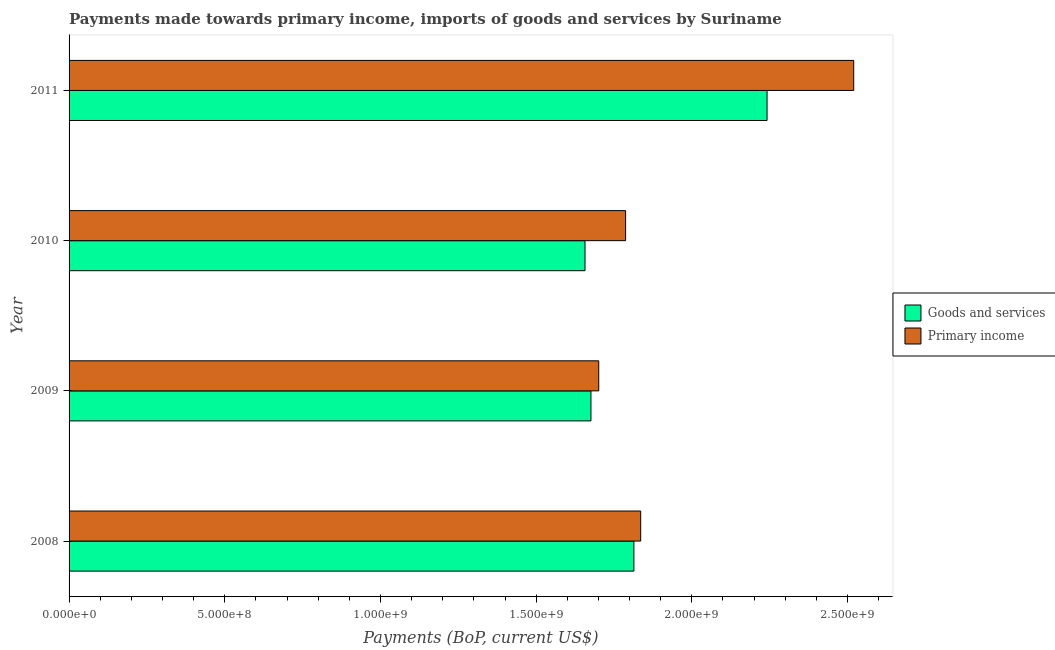How many different coloured bars are there?
Provide a succinct answer. 2. Are the number of bars on each tick of the Y-axis equal?
Provide a short and direct response. Yes. How many bars are there on the 3rd tick from the top?
Your answer should be compact. 2. What is the label of the 1st group of bars from the top?
Provide a succinct answer. 2011. In how many cases, is the number of bars for a given year not equal to the number of legend labels?
Give a very brief answer. 0. What is the payments made towards primary income in 2010?
Keep it short and to the point. 1.79e+09. Across all years, what is the maximum payments made towards primary income?
Give a very brief answer. 2.52e+09. Across all years, what is the minimum payments made towards goods and services?
Give a very brief answer. 1.66e+09. In which year was the payments made towards goods and services minimum?
Your answer should be very brief. 2010. What is the total payments made towards goods and services in the graph?
Make the answer very short. 7.39e+09. What is the difference between the payments made towards primary income in 2009 and that in 2011?
Give a very brief answer. -8.19e+08. What is the difference between the payments made towards goods and services in 2010 and the payments made towards primary income in 2008?
Offer a very short reply. -1.79e+08. What is the average payments made towards goods and services per year?
Give a very brief answer. 1.85e+09. In the year 2009, what is the difference between the payments made towards goods and services and payments made towards primary income?
Provide a short and direct response. -2.50e+07. What is the ratio of the payments made towards goods and services in 2010 to that in 2011?
Your answer should be very brief. 0.74. Is the difference between the payments made towards primary income in 2008 and 2010 greater than the difference between the payments made towards goods and services in 2008 and 2010?
Provide a succinct answer. No. What is the difference between the highest and the second highest payments made towards goods and services?
Your response must be concise. 4.28e+08. What is the difference between the highest and the lowest payments made towards primary income?
Your answer should be very brief. 8.19e+08. Is the sum of the payments made towards primary income in 2008 and 2011 greater than the maximum payments made towards goods and services across all years?
Your answer should be very brief. Yes. What does the 1st bar from the top in 2009 represents?
Your answer should be compact. Primary income. What does the 2nd bar from the bottom in 2011 represents?
Your answer should be very brief. Primary income. How many bars are there?
Keep it short and to the point. 8. Are all the bars in the graph horizontal?
Your response must be concise. Yes. Does the graph contain grids?
Offer a very short reply. No. How are the legend labels stacked?
Offer a terse response. Vertical. What is the title of the graph?
Provide a short and direct response. Payments made towards primary income, imports of goods and services by Suriname. Does "Female population" appear as one of the legend labels in the graph?
Provide a short and direct response. No. What is the label or title of the X-axis?
Your answer should be very brief. Payments (BoP, current US$). What is the label or title of the Y-axis?
Provide a succinct answer. Year. What is the Payments (BoP, current US$) of Goods and services in 2008?
Your response must be concise. 1.81e+09. What is the Payments (BoP, current US$) of Primary income in 2008?
Give a very brief answer. 1.84e+09. What is the Payments (BoP, current US$) in Goods and services in 2009?
Make the answer very short. 1.68e+09. What is the Payments (BoP, current US$) in Primary income in 2009?
Offer a very short reply. 1.70e+09. What is the Payments (BoP, current US$) of Goods and services in 2010?
Give a very brief answer. 1.66e+09. What is the Payments (BoP, current US$) in Primary income in 2010?
Offer a very short reply. 1.79e+09. What is the Payments (BoP, current US$) of Goods and services in 2011?
Your response must be concise. 2.24e+09. What is the Payments (BoP, current US$) of Primary income in 2011?
Provide a succinct answer. 2.52e+09. Across all years, what is the maximum Payments (BoP, current US$) of Goods and services?
Ensure brevity in your answer.  2.24e+09. Across all years, what is the maximum Payments (BoP, current US$) in Primary income?
Your answer should be very brief. 2.52e+09. Across all years, what is the minimum Payments (BoP, current US$) in Goods and services?
Your answer should be compact. 1.66e+09. Across all years, what is the minimum Payments (BoP, current US$) in Primary income?
Offer a very short reply. 1.70e+09. What is the total Payments (BoP, current US$) in Goods and services in the graph?
Offer a very short reply. 7.39e+09. What is the total Payments (BoP, current US$) in Primary income in the graph?
Provide a short and direct response. 7.84e+09. What is the difference between the Payments (BoP, current US$) in Goods and services in 2008 and that in 2009?
Your answer should be compact. 1.38e+08. What is the difference between the Payments (BoP, current US$) of Primary income in 2008 and that in 2009?
Make the answer very short. 1.35e+08. What is the difference between the Payments (BoP, current US$) in Goods and services in 2008 and that in 2010?
Give a very brief answer. 1.57e+08. What is the difference between the Payments (BoP, current US$) of Primary income in 2008 and that in 2010?
Your answer should be compact. 4.84e+07. What is the difference between the Payments (BoP, current US$) in Goods and services in 2008 and that in 2011?
Offer a very short reply. -4.28e+08. What is the difference between the Payments (BoP, current US$) of Primary income in 2008 and that in 2011?
Ensure brevity in your answer.  -6.84e+08. What is the difference between the Payments (BoP, current US$) of Goods and services in 2009 and that in 2010?
Provide a succinct answer. 1.91e+07. What is the difference between the Payments (BoP, current US$) of Primary income in 2009 and that in 2010?
Your answer should be compact. -8.63e+07. What is the difference between the Payments (BoP, current US$) of Goods and services in 2009 and that in 2011?
Provide a succinct answer. -5.66e+08. What is the difference between the Payments (BoP, current US$) in Primary income in 2009 and that in 2011?
Give a very brief answer. -8.19e+08. What is the difference between the Payments (BoP, current US$) of Goods and services in 2010 and that in 2011?
Keep it short and to the point. -5.85e+08. What is the difference between the Payments (BoP, current US$) of Primary income in 2010 and that in 2011?
Your answer should be compact. -7.33e+08. What is the difference between the Payments (BoP, current US$) in Goods and services in 2008 and the Payments (BoP, current US$) in Primary income in 2009?
Your answer should be very brief. 1.13e+08. What is the difference between the Payments (BoP, current US$) of Goods and services in 2008 and the Payments (BoP, current US$) of Primary income in 2010?
Make the answer very short. 2.66e+07. What is the difference between the Payments (BoP, current US$) in Goods and services in 2008 and the Payments (BoP, current US$) in Primary income in 2011?
Keep it short and to the point. -7.06e+08. What is the difference between the Payments (BoP, current US$) in Goods and services in 2009 and the Payments (BoP, current US$) in Primary income in 2010?
Ensure brevity in your answer.  -1.11e+08. What is the difference between the Payments (BoP, current US$) of Goods and services in 2009 and the Payments (BoP, current US$) of Primary income in 2011?
Ensure brevity in your answer.  -8.44e+08. What is the difference between the Payments (BoP, current US$) of Goods and services in 2010 and the Payments (BoP, current US$) of Primary income in 2011?
Your answer should be very brief. -8.63e+08. What is the average Payments (BoP, current US$) in Goods and services per year?
Provide a succinct answer. 1.85e+09. What is the average Payments (BoP, current US$) of Primary income per year?
Your answer should be compact. 1.96e+09. In the year 2008, what is the difference between the Payments (BoP, current US$) in Goods and services and Payments (BoP, current US$) in Primary income?
Give a very brief answer. -2.18e+07. In the year 2009, what is the difference between the Payments (BoP, current US$) of Goods and services and Payments (BoP, current US$) of Primary income?
Your response must be concise. -2.50e+07. In the year 2010, what is the difference between the Payments (BoP, current US$) in Goods and services and Payments (BoP, current US$) in Primary income?
Offer a terse response. -1.30e+08. In the year 2011, what is the difference between the Payments (BoP, current US$) in Goods and services and Payments (BoP, current US$) in Primary income?
Keep it short and to the point. -2.78e+08. What is the ratio of the Payments (BoP, current US$) in Goods and services in 2008 to that in 2009?
Offer a very short reply. 1.08. What is the ratio of the Payments (BoP, current US$) in Primary income in 2008 to that in 2009?
Keep it short and to the point. 1.08. What is the ratio of the Payments (BoP, current US$) in Goods and services in 2008 to that in 2010?
Provide a succinct answer. 1.09. What is the ratio of the Payments (BoP, current US$) of Primary income in 2008 to that in 2010?
Offer a very short reply. 1.03. What is the ratio of the Payments (BoP, current US$) in Goods and services in 2008 to that in 2011?
Offer a very short reply. 0.81. What is the ratio of the Payments (BoP, current US$) of Primary income in 2008 to that in 2011?
Give a very brief answer. 0.73. What is the ratio of the Payments (BoP, current US$) in Goods and services in 2009 to that in 2010?
Your answer should be very brief. 1.01. What is the ratio of the Payments (BoP, current US$) in Primary income in 2009 to that in 2010?
Make the answer very short. 0.95. What is the ratio of the Payments (BoP, current US$) in Goods and services in 2009 to that in 2011?
Offer a very short reply. 0.75. What is the ratio of the Payments (BoP, current US$) in Primary income in 2009 to that in 2011?
Your answer should be compact. 0.68. What is the ratio of the Payments (BoP, current US$) in Goods and services in 2010 to that in 2011?
Offer a terse response. 0.74. What is the ratio of the Payments (BoP, current US$) of Primary income in 2010 to that in 2011?
Give a very brief answer. 0.71. What is the difference between the highest and the second highest Payments (BoP, current US$) in Goods and services?
Provide a short and direct response. 4.28e+08. What is the difference between the highest and the second highest Payments (BoP, current US$) in Primary income?
Provide a succinct answer. 6.84e+08. What is the difference between the highest and the lowest Payments (BoP, current US$) in Goods and services?
Offer a very short reply. 5.85e+08. What is the difference between the highest and the lowest Payments (BoP, current US$) in Primary income?
Your response must be concise. 8.19e+08. 